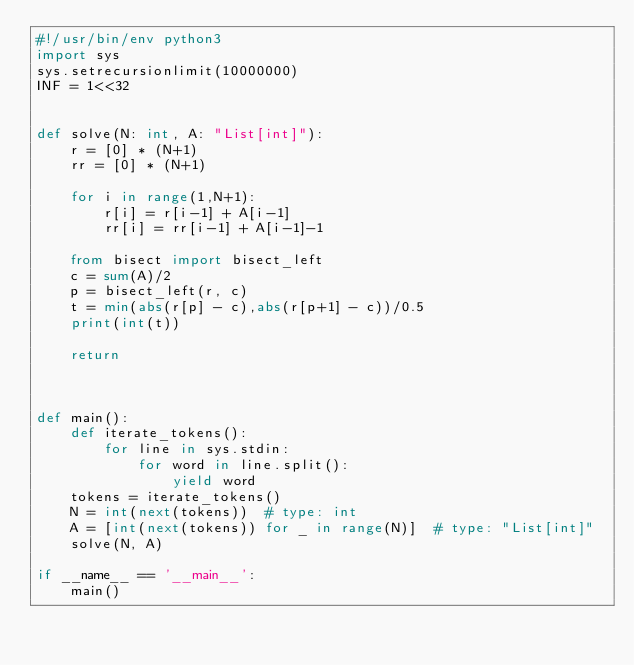Convert code to text. <code><loc_0><loc_0><loc_500><loc_500><_Python_>#!/usr/bin/env python3
import sys
sys.setrecursionlimit(10000000)
INF = 1<<32


def solve(N: int, A: "List[int]"):
    r = [0] * (N+1)
    rr = [0] * (N+1)

    for i in range(1,N+1):
        r[i] = r[i-1] + A[i-1]
        rr[i] = rr[i-1] + A[i-1]-1

    from bisect import bisect_left
    c = sum(A)/2
    p = bisect_left(r, c)
    t = min(abs(r[p] - c),abs(r[p+1] - c))/0.5
    print(int(t))

    return



def main():
    def iterate_tokens():
        for line in sys.stdin:
            for word in line.split():
                yield word
    tokens = iterate_tokens()
    N = int(next(tokens))  # type: int
    A = [int(next(tokens)) for _ in range(N)]  # type: "List[int]"
    solve(N, A)

if __name__ == '__main__':
    main()
</code> 